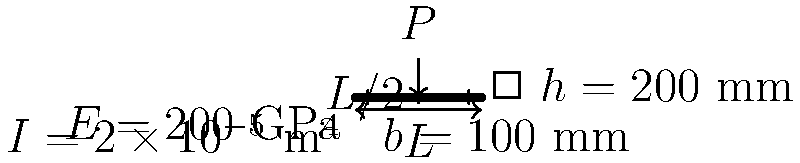A simply supported beam of length $L = 5$ m is subjected to a point load $P = 50$ kN at its midspan. The beam is made of steel with Young's modulus $E = 200$ GPa and has a rectangular cross-section with width $b = 100$ mm and height $h = 200$ mm. Calculate the maximum deflection of the beam. To calculate the maximum deflection of the beam, we'll follow these steps:

1. Calculate the moment of inertia (I) for the rectangular cross-section:
   $$I = \frac{bh^3}{12} = \frac{0.1 \times 0.2^3}{12} = 6.67 \times 10^{-5} \text{ m}^4$$

2. Use the formula for maximum deflection of a simply supported beam with a point load at midspan:
   $$\delta_{\text{max}} = \frac{PL^3}{48EI}$$

   Where:
   $\delta_{\text{max}}$ = maximum deflection
   $P$ = point load
   $L$ = beam length
   $E$ = Young's modulus
   $I$ = moment of inertia

3. Substitute the given values:
   $$\delta_{\text{max}} = \frac{50,000 \times 5^3}{48 \times 200 \times 10^9 \times 6.67 \times 10^{-5}}$$

4. Calculate the result:
   $$\delta_{\text{max}} = 0.00391 \text{ m} = 3.91 \text{ mm}$$

Therefore, the maximum deflection of the beam is 3.91 mm.
Answer: 3.91 mm 